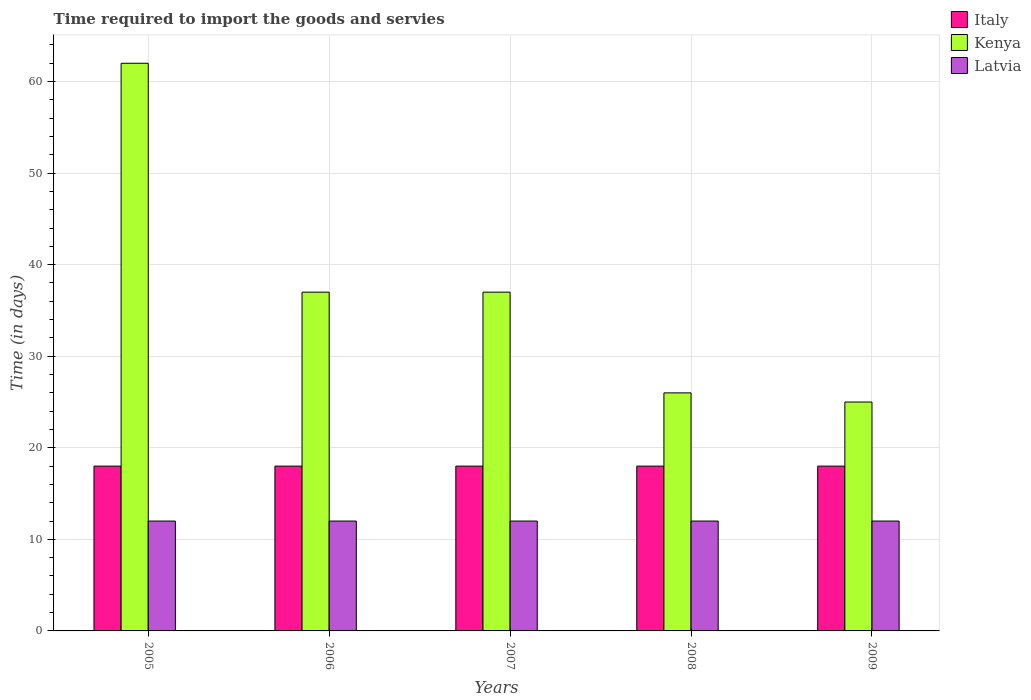How many groups of bars are there?
Make the answer very short. 5. What is the number of days required to import the goods and services in Latvia in 2009?
Give a very brief answer. 12. Across all years, what is the maximum number of days required to import the goods and services in Italy?
Provide a succinct answer. 18. Across all years, what is the minimum number of days required to import the goods and services in Kenya?
Offer a very short reply. 25. In which year was the number of days required to import the goods and services in Italy minimum?
Give a very brief answer. 2005. What is the total number of days required to import the goods and services in Kenya in the graph?
Offer a very short reply. 187. What is the difference between the number of days required to import the goods and services in Latvia in 2009 and the number of days required to import the goods and services in Kenya in 2006?
Your answer should be very brief. -25. What is the average number of days required to import the goods and services in Italy per year?
Provide a short and direct response. 18. In the year 2005, what is the difference between the number of days required to import the goods and services in Italy and number of days required to import the goods and services in Kenya?
Offer a terse response. -44. What is the ratio of the number of days required to import the goods and services in Italy in 2005 to that in 2009?
Ensure brevity in your answer.  1. Is the number of days required to import the goods and services in Kenya in 2005 less than that in 2006?
Your answer should be very brief. No. What is the difference between the highest and the lowest number of days required to import the goods and services in Italy?
Offer a very short reply. 0. In how many years, is the number of days required to import the goods and services in Kenya greater than the average number of days required to import the goods and services in Kenya taken over all years?
Provide a succinct answer. 1. What does the 1st bar from the left in 2009 represents?
Your answer should be compact. Italy. What does the 3rd bar from the right in 2005 represents?
Offer a terse response. Italy. How many bars are there?
Offer a very short reply. 15. Are all the bars in the graph horizontal?
Offer a terse response. No. Does the graph contain grids?
Give a very brief answer. Yes. What is the title of the graph?
Keep it short and to the point. Time required to import the goods and servies. Does "Uzbekistan" appear as one of the legend labels in the graph?
Give a very brief answer. No. What is the label or title of the X-axis?
Keep it short and to the point. Years. What is the label or title of the Y-axis?
Make the answer very short. Time (in days). What is the Time (in days) of Kenya in 2006?
Give a very brief answer. 37. What is the Time (in days) of Kenya in 2007?
Offer a terse response. 37. What is the Time (in days) of Latvia in 2007?
Ensure brevity in your answer.  12. What is the Time (in days) of Italy in 2008?
Your response must be concise. 18. What is the Time (in days) of Kenya in 2008?
Provide a short and direct response. 26. What is the Time (in days) in Latvia in 2008?
Your answer should be very brief. 12. What is the Time (in days) in Italy in 2009?
Give a very brief answer. 18. What is the Time (in days) in Latvia in 2009?
Provide a short and direct response. 12. Across all years, what is the maximum Time (in days) in Italy?
Ensure brevity in your answer.  18. Across all years, what is the maximum Time (in days) of Kenya?
Make the answer very short. 62. Across all years, what is the maximum Time (in days) of Latvia?
Keep it short and to the point. 12. What is the total Time (in days) of Italy in the graph?
Keep it short and to the point. 90. What is the total Time (in days) in Kenya in the graph?
Your answer should be very brief. 187. What is the difference between the Time (in days) of Italy in 2005 and that in 2006?
Provide a succinct answer. 0. What is the difference between the Time (in days) of Latvia in 2005 and that in 2006?
Your answer should be compact. 0. What is the difference between the Time (in days) in Italy in 2005 and that in 2007?
Offer a terse response. 0. What is the difference between the Time (in days) of Kenya in 2005 and that in 2007?
Make the answer very short. 25. What is the difference between the Time (in days) in Latvia in 2005 and that in 2007?
Give a very brief answer. 0. What is the difference between the Time (in days) of Italy in 2005 and that in 2008?
Your answer should be very brief. 0. What is the difference between the Time (in days) in Italy in 2005 and that in 2009?
Your answer should be very brief. 0. What is the difference between the Time (in days) in Kenya in 2005 and that in 2009?
Your answer should be compact. 37. What is the difference between the Time (in days) of Latvia in 2005 and that in 2009?
Your answer should be very brief. 0. What is the difference between the Time (in days) of Kenya in 2006 and that in 2007?
Your answer should be compact. 0. What is the difference between the Time (in days) of Italy in 2006 and that in 2008?
Your response must be concise. 0. What is the difference between the Time (in days) of Latvia in 2006 and that in 2008?
Keep it short and to the point. 0. What is the difference between the Time (in days) in Kenya in 2006 and that in 2009?
Ensure brevity in your answer.  12. What is the difference between the Time (in days) of Latvia in 2006 and that in 2009?
Offer a terse response. 0. What is the difference between the Time (in days) of Italy in 2007 and that in 2008?
Ensure brevity in your answer.  0. What is the difference between the Time (in days) of Kenya in 2007 and that in 2008?
Ensure brevity in your answer.  11. What is the difference between the Time (in days) of Latvia in 2007 and that in 2008?
Your answer should be compact. 0. What is the difference between the Time (in days) in Italy in 2007 and that in 2009?
Provide a succinct answer. 0. What is the difference between the Time (in days) of Kenya in 2007 and that in 2009?
Provide a succinct answer. 12. What is the difference between the Time (in days) of Latvia in 2007 and that in 2009?
Ensure brevity in your answer.  0. What is the difference between the Time (in days) in Kenya in 2008 and that in 2009?
Offer a very short reply. 1. What is the difference between the Time (in days) of Italy in 2005 and the Time (in days) of Kenya in 2006?
Your answer should be very brief. -19. What is the difference between the Time (in days) of Italy in 2005 and the Time (in days) of Latvia in 2007?
Provide a short and direct response. 6. What is the difference between the Time (in days) in Kenya in 2005 and the Time (in days) in Latvia in 2007?
Ensure brevity in your answer.  50. What is the difference between the Time (in days) in Italy in 2005 and the Time (in days) in Kenya in 2008?
Keep it short and to the point. -8. What is the difference between the Time (in days) of Italy in 2005 and the Time (in days) of Kenya in 2009?
Give a very brief answer. -7. What is the difference between the Time (in days) in Italy in 2005 and the Time (in days) in Latvia in 2009?
Give a very brief answer. 6. What is the difference between the Time (in days) of Kenya in 2005 and the Time (in days) of Latvia in 2009?
Your response must be concise. 50. What is the difference between the Time (in days) of Italy in 2006 and the Time (in days) of Kenya in 2007?
Your answer should be very brief. -19. What is the difference between the Time (in days) of Italy in 2006 and the Time (in days) of Latvia in 2007?
Make the answer very short. 6. What is the difference between the Time (in days) of Kenya in 2006 and the Time (in days) of Latvia in 2008?
Offer a terse response. 25. What is the difference between the Time (in days) in Italy in 2006 and the Time (in days) in Latvia in 2009?
Your response must be concise. 6. What is the difference between the Time (in days) in Italy in 2007 and the Time (in days) in Latvia in 2008?
Give a very brief answer. 6. What is the difference between the Time (in days) in Kenya in 2007 and the Time (in days) in Latvia in 2008?
Offer a terse response. 25. What is the difference between the Time (in days) in Italy in 2007 and the Time (in days) in Kenya in 2009?
Your answer should be compact. -7. What is the difference between the Time (in days) in Italy in 2007 and the Time (in days) in Latvia in 2009?
Your answer should be very brief. 6. What is the difference between the Time (in days) of Italy in 2008 and the Time (in days) of Latvia in 2009?
Give a very brief answer. 6. What is the average Time (in days) of Italy per year?
Offer a terse response. 18. What is the average Time (in days) of Kenya per year?
Make the answer very short. 37.4. In the year 2005, what is the difference between the Time (in days) of Italy and Time (in days) of Kenya?
Make the answer very short. -44. In the year 2005, what is the difference between the Time (in days) in Italy and Time (in days) in Latvia?
Give a very brief answer. 6. In the year 2005, what is the difference between the Time (in days) in Kenya and Time (in days) in Latvia?
Provide a succinct answer. 50. In the year 2006, what is the difference between the Time (in days) of Kenya and Time (in days) of Latvia?
Give a very brief answer. 25. In the year 2007, what is the difference between the Time (in days) in Italy and Time (in days) in Latvia?
Ensure brevity in your answer.  6. In the year 2007, what is the difference between the Time (in days) in Kenya and Time (in days) in Latvia?
Provide a succinct answer. 25. In the year 2008, what is the difference between the Time (in days) in Italy and Time (in days) in Kenya?
Your answer should be compact. -8. In the year 2008, what is the difference between the Time (in days) of Italy and Time (in days) of Latvia?
Your answer should be very brief. 6. In the year 2009, what is the difference between the Time (in days) of Italy and Time (in days) of Kenya?
Give a very brief answer. -7. In the year 2009, what is the difference between the Time (in days) in Italy and Time (in days) in Latvia?
Make the answer very short. 6. What is the ratio of the Time (in days) in Italy in 2005 to that in 2006?
Ensure brevity in your answer.  1. What is the ratio of the Time (in days) in Kenya in 2005 to that in 2006?
Your answer should be very brief. 1.68. What is the ratio of the Time (in days) in Kenya in 2005 to that in 2007?
Your answer should be very brief. 1.68. What is the ratio of the Time (in days) of Latvia in 2005 to that in 2007?
Provide a succinct answer. 1. What is the ratio of the Time (in days) of Italy in 2005 to that in 2008?
Offer a very short reply. 1. What is the ratio of the Time (in days) of Kenya in 2005 to that in 2008?
Offer a terse response. 2.38. What is the ratio of the Time (in days) of Kenya in 2005 to that in 2009?
Provide a short and direct response. 2.48. What is the ratio of the Time (in days) of Latvia in 2005 to that in 2009?
Provide a short and direct response. 1. What is the ratio of the Time (in days) of Italy in 2006 to that in 2007?
Ensure brevity in your answer.  1. What is the ratio of the Time (in days) of Kenya in 2006 to that in 2007?
Your answer should be very brief. 1. What is the ratio of the Time (in days) of Kenya in 2006 to that in 2008?
Offer a very short reply. 1.42. What is the ratio of the Time (in days) of Latvia in 2006 to that in 2008?
Ensure brevity in your answer.  1. What is the ratio of the Time (in days) of Italy in 2006 to that in 2009?
Your response must be concise. 1. What is the ratio of the Time (in days) in Kenya in 2006 to that in 2009?
Ensure brevity in your answer.  1.48. What is the ratio of the Time (in days) in Latvia in 2006 to that in 2009?
Provide a short and direct response. 1. What is the ratio of the Time (in days) in Kenya in 2007 to that in 2008?
Offer a terse response. 1.42. What is the ratio of the Time (in days) of Kenya in 2007 to that in 2009?
Give a very brief answer. 1.48. What is the ratio of the Time (in days) in Latvia in 2007 to that in 2009?
Your answer should be very brief. 1. What is the ratio of the Time (in days) in Italy in 2008 to that in 2009?
Your response must be concise. 1. What is the ratio of the Time (in days) of Kenya in 2008 to that in 2009?
Your answer should be very brief. 1.04. What is the difference between the highest and the lowest Time (in days) of Kenya?
Offer a very short reply. 37. What is the difference between the highest and the lowest Time (in days) in Latvia?
Offer a terse response. 0. 